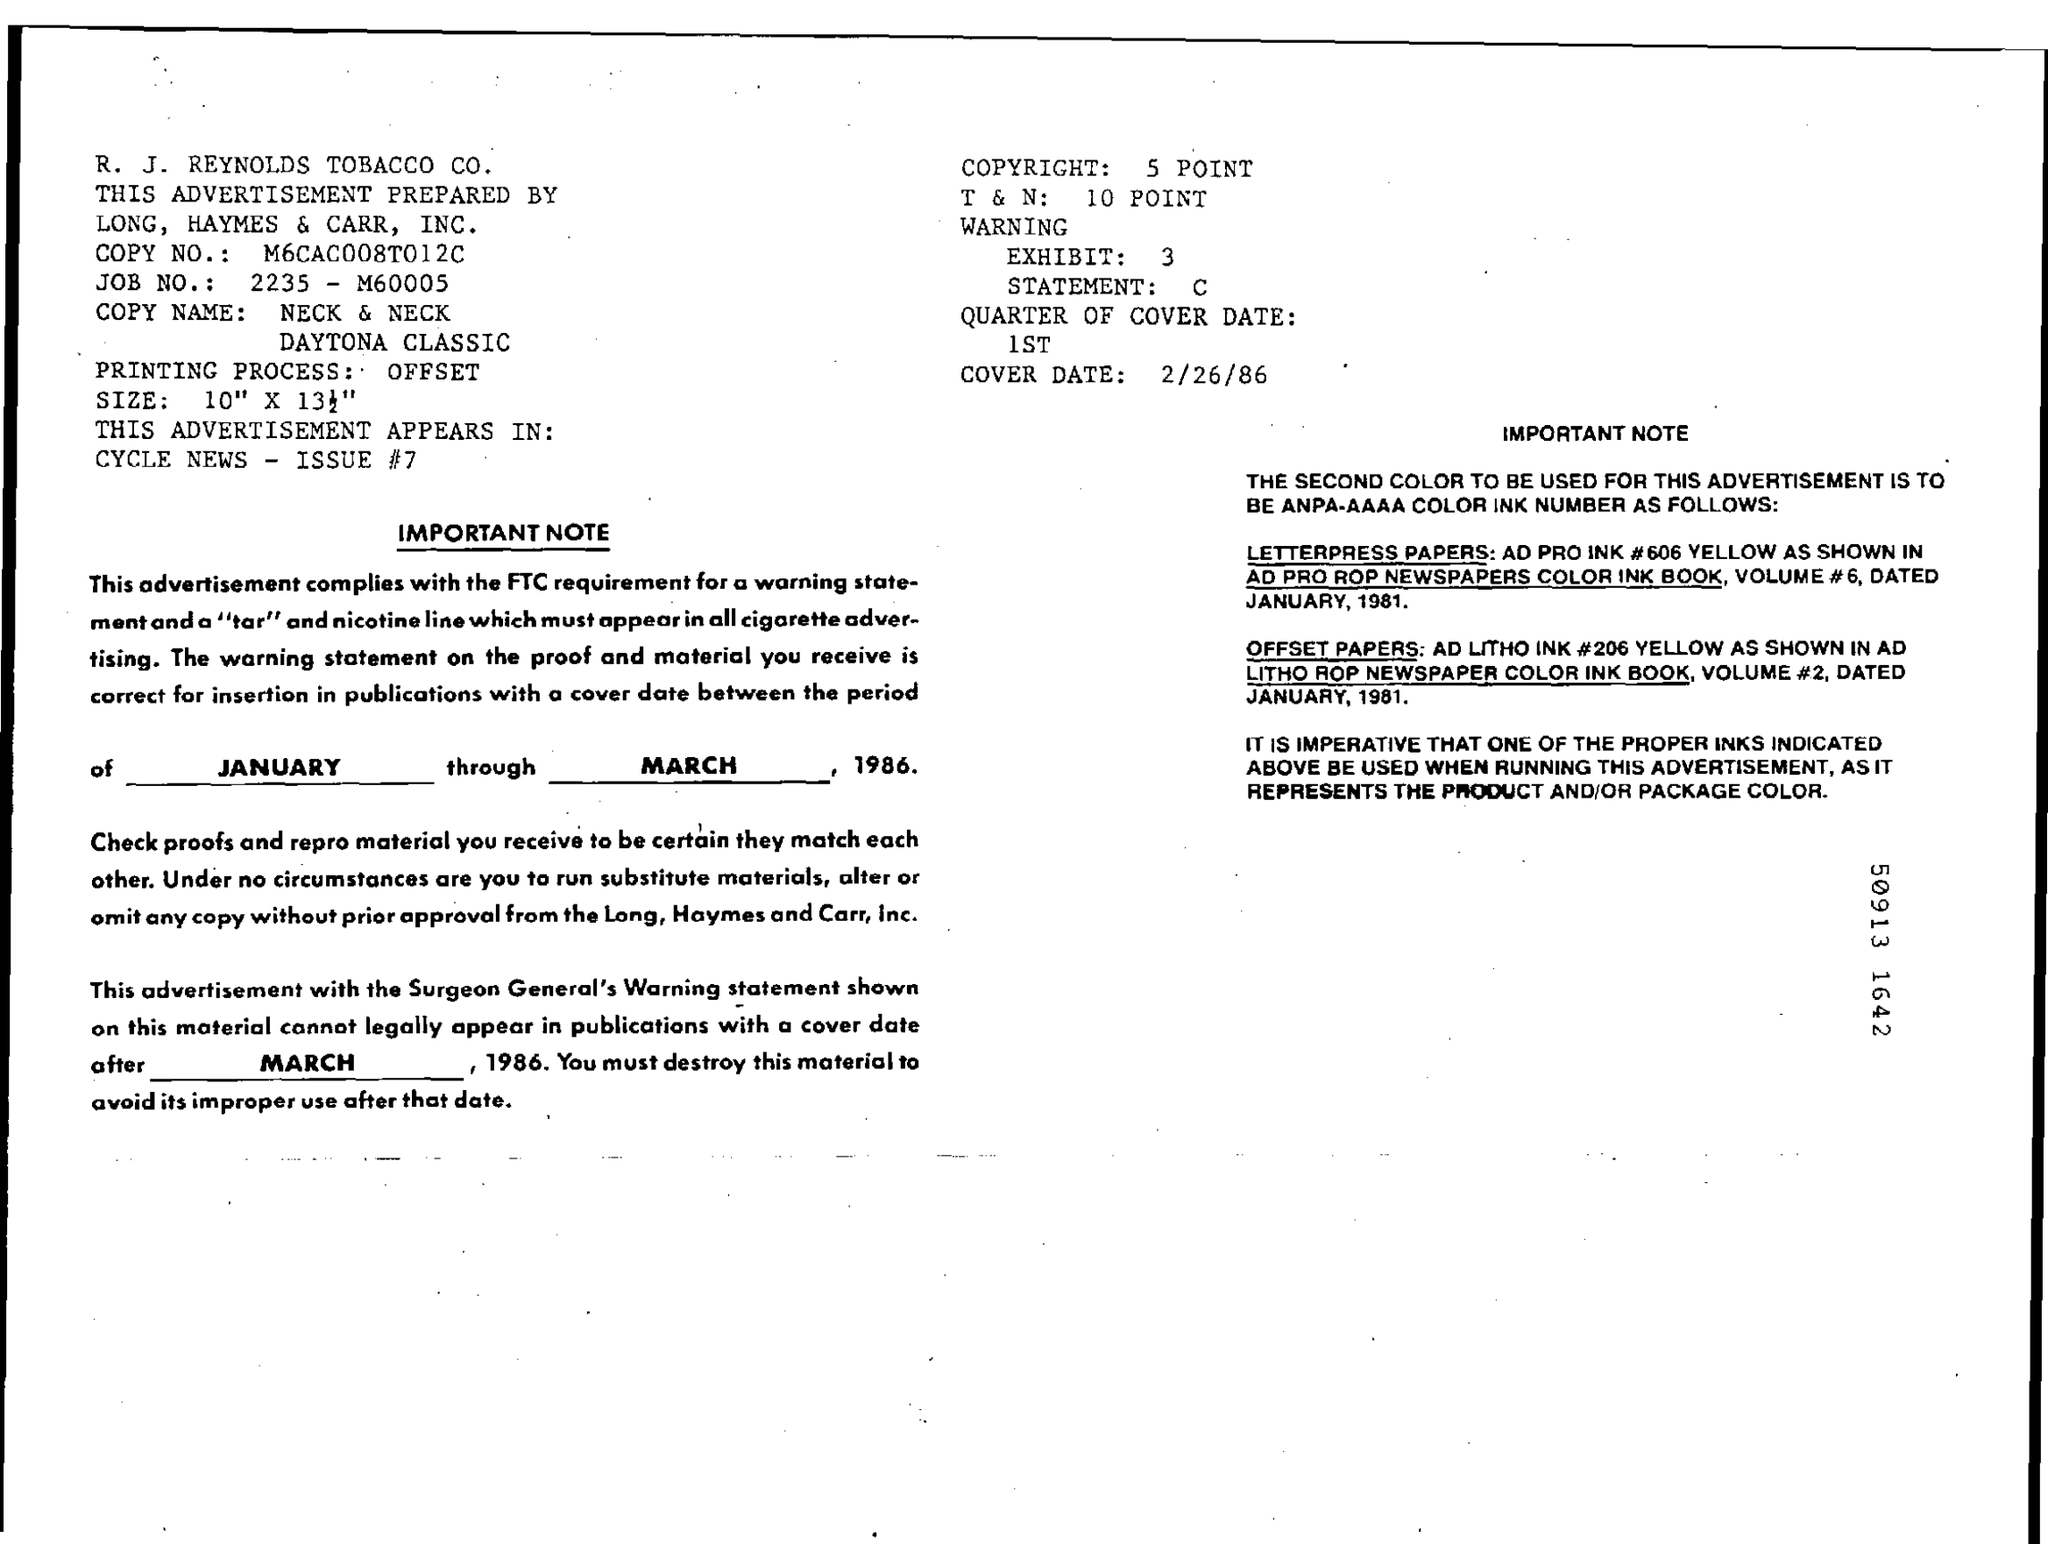This advertisement was prepared by?
Offer a terse response. LONG,  HAYMES & CARR, INC. What is the cover date?
Provide a short and direct response. 2/26/86. What is the job number?
Make the answer very short. 2235-M60005. 